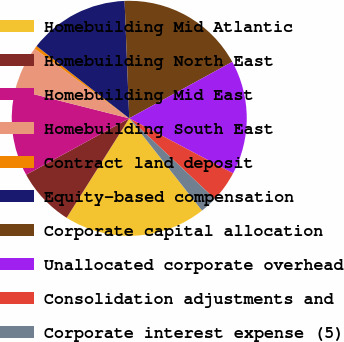Convert chart to OTSL. <chart><loc_0><loc_0><loc_500><loc_500><pie_chart><fcel>Homebuilding Mid Atlantic<fcel>Homebuilding North East<fcel>Homebuilding Mid East<fcel>Homebuilding South East<fcel>Contract land deposit<fcel>Equity-based compensation<fcel>Corporate capital allocation<fcel>Unallocated corporate overhead<fcel>Consolidation adjustments and<fcel>Corporate interest expense (5)<nl><fcel>19.57%<fcel>8.09%<fcel>11.91%<fcel>6.17%<fcel>0.43%<fcel>13.83%<fcel>17.65%<fcel>15.74%<fcel>4.26%<fcel>2.35%<nl></chart> 